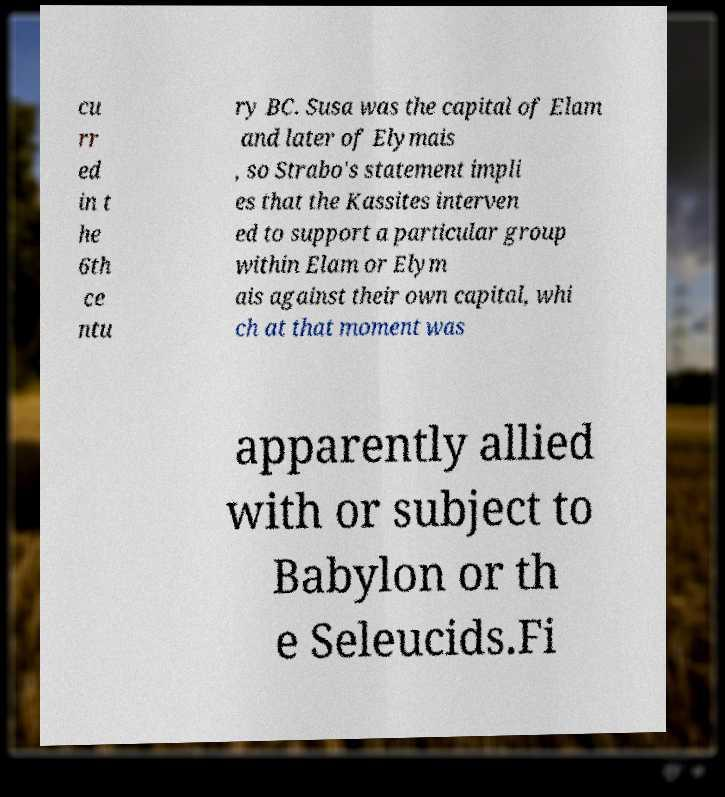There's text embedded in this image that I need extracted. Can you transcribe it verbatim? cu rr ed in t he 6th ce ntu ry BC. Susa was the capital of Elam and later of Elymais , so Strabo's statement impli es that the Kassites interven ed to support a particular group within Elam or Elym ais against their own capital, whi ch at that moment was apparently allied with or subject to Babylon or th e Seleucids.Fi 